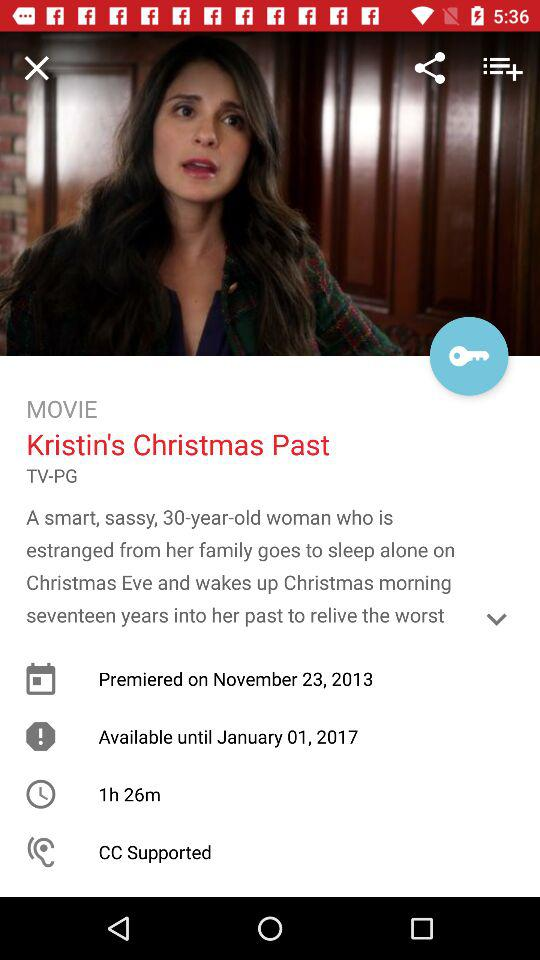What genre is the movie?
When the provided information is insufficient, respond with <no answer>. <no answer> 